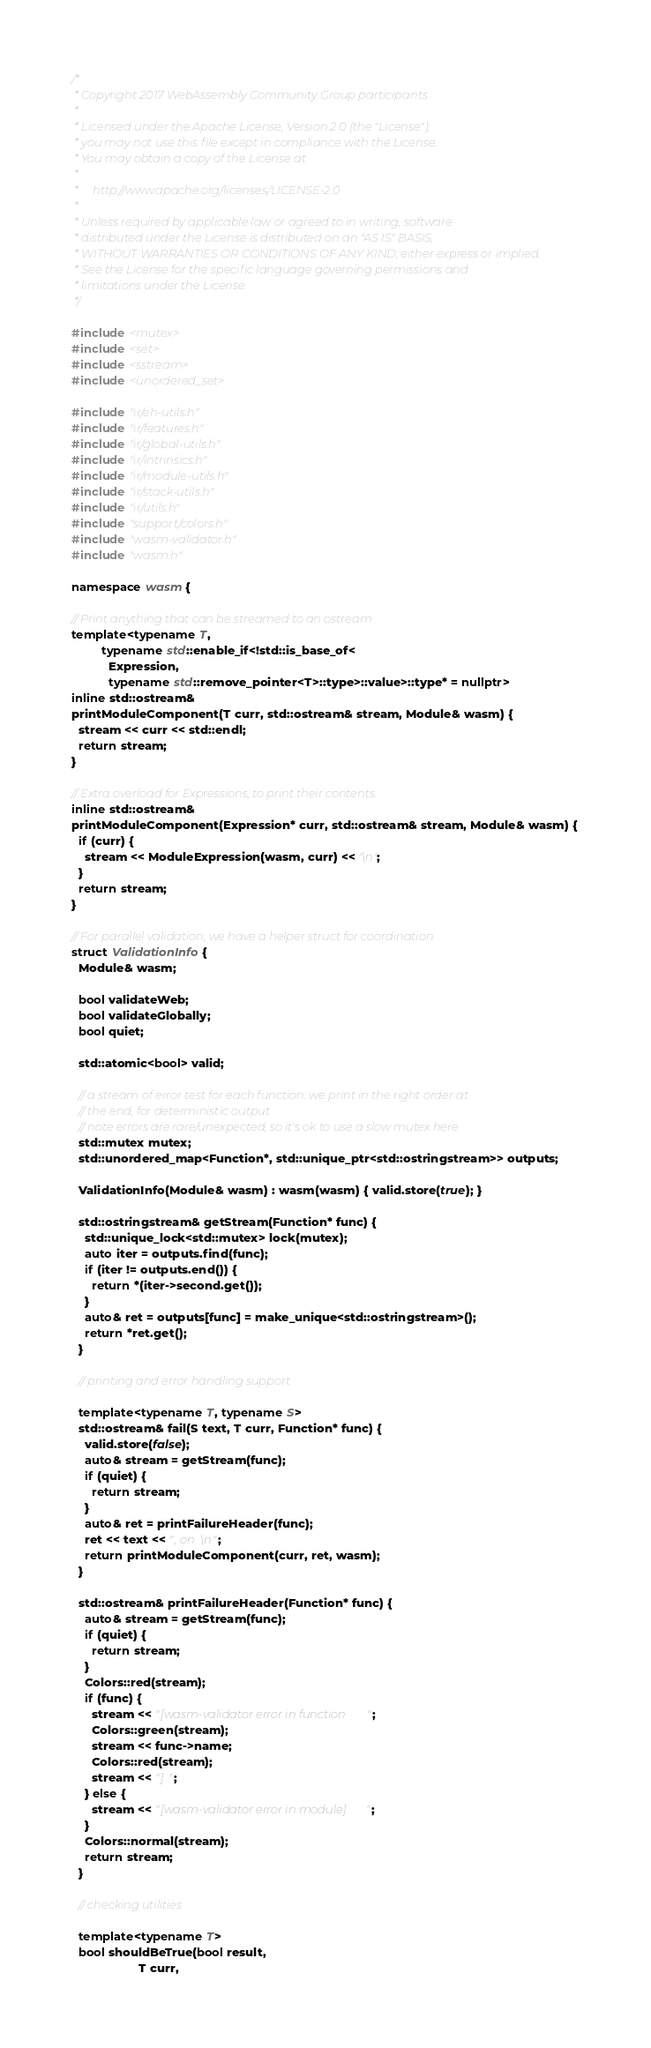<code> <loc_0><loc_0><loc_500><loc_500><_C++_>/*
 * Copyright 2017 WebAssembly Community Group participants
 *
 * Licensed under the Apache License, Version 2.0 (the "License");
 * you may not use this file except in compliance with the License.
 * You may obtain a copy of the License at
 *
 *     http://www.apache.org/licenses/LICENSE-2.0
 *
 * Unless required by applicable law or agreed to in writing, software
 * distributed under the License is distributed on an "AS IS" BASIS,
 * WITHOUT WARRANTIES OR CONDITIONS OF ANY KIND, either express or implied.
 * See the License for the specific language governing permissions and
 * limitations under the License.
 */

#include <mutex>
#include <set>
#include <sstream>
#include <unordered_set>

#include "ir/eh-utils.h"
#include "ir/features.h"
#include "ir/global-utils.h"
#include "ir/intrinsics.h"
#include "ir/module-utils.h"
#include "ir/stack-utils.h"
#include "ir/utils.h"
#include "support/colors.h"
#include "wasm-validator.h"
#include "wasm.h"

namespace wasm {

// Print anything that can be streamed to an ostream
template<typename T,
         typename std::enable_if<!std::is_base_of<
           Expression,
           typename std::remove_pointer<T>::type>::value>::type* = nullptr>
inline std::ostream&
printModuleComponent(T curr, std::ostream& stream, Module& wasm) {
  stream << curr << std::endl;
  return stream;
}

// Extra overload for Expressions, to print their contents.
inline std::ostream&
printModuleComponent(Expression* curr, std::ostream& stream, Module& wasm) {
  if (curr) {
    stream << ModuleExpression(wasm, curr) << '\n';
  }
  return stream;
}

// For parallel validation, we have a helper struct for coordination
struct ValidationInfo {
  Module& wasm;

  bool validateWeb;
  bool validateGlobally;
  bool quiet;

  std::atomic<bool> valid;

  // a stream of error test for each function. we print in the right order at
  // the end, for deterministic output
  // note errors are rare/unexpected, so it's ok to use a slow mutex here
  std::mutex mutex;
  std::unordered_map<Function*, std::unique_ptr<std::ostringstream>> outputs;

  ValidationInfo(Module& wasm) : wasm(wasm) { valid.store(true); }

  std::ostringstream& getStream(Function* func) {
    std::unique_lock<std::mutex> lock(mutex);
    auto iter = outputs.find(func);
    if (iter != outputs.end()) {
      return *(iter->second.get());
    }
    auto& ret = outputs[func] = make_unique<std::ostringstream>();
    return *ret.get();
  }

  // printing and error handling support

  template<typename T, typename S>
  std::ostream& fail(S text, T curr, Function* func) {
    valid.store(false);
    auto& stream = getStream(func);
    if (quiet) {
      return stream;
    }
    auto& ret = printFailureHeader(func);
    ret << text << ", on \n";
    return printModuleComponent(curr, ret, wasm);
  }

  std::ostream& printFailureHeader(Function* func) {
    auto& stream = getStream(func);
    if (quiet) {
      return stream;
    }
    Colors::red(stream);
    if (func) {
      stream << "[wasm-validator error in function ";
      Colors::green(stream);
      stream << func->name;
      Colors::red(stream);
      stream << "] ";
    } else {
      stream << "[wasm-validator error in module] ";
    }
    Colors::normal(stream);
    return stream;
  }

  // checking utilities

  template<typename T>
  bool shouldBeTrue(bool result,
                    T curr,</code> 